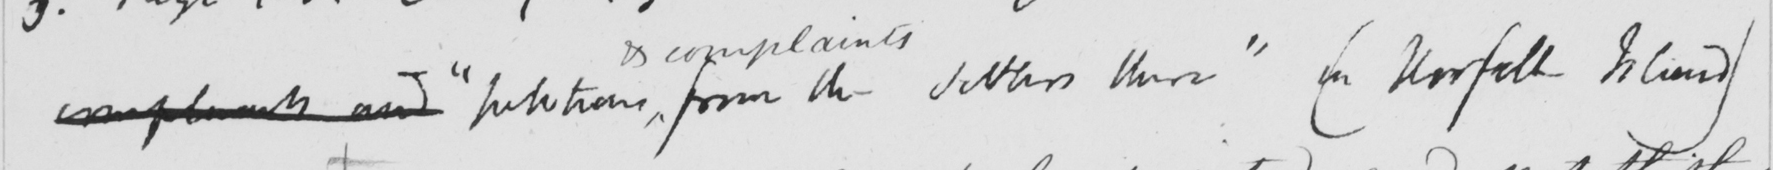Can you tell me what this handwritten text says? complaints and  " petitions from the settlers there  ( on Norfolk Island ) 